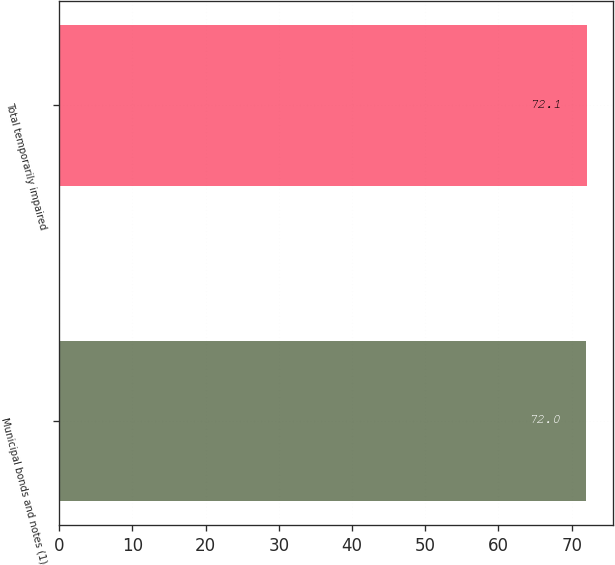Convert chart to OTSL. <chart><loc_0><loc_0><loc_500><loc_500><bar_chart><fcel>Municipal bonds and notes (1)<fcel>Total temporarily impaired<nl><fcel>72<fcel>72.1<nl></chart> 